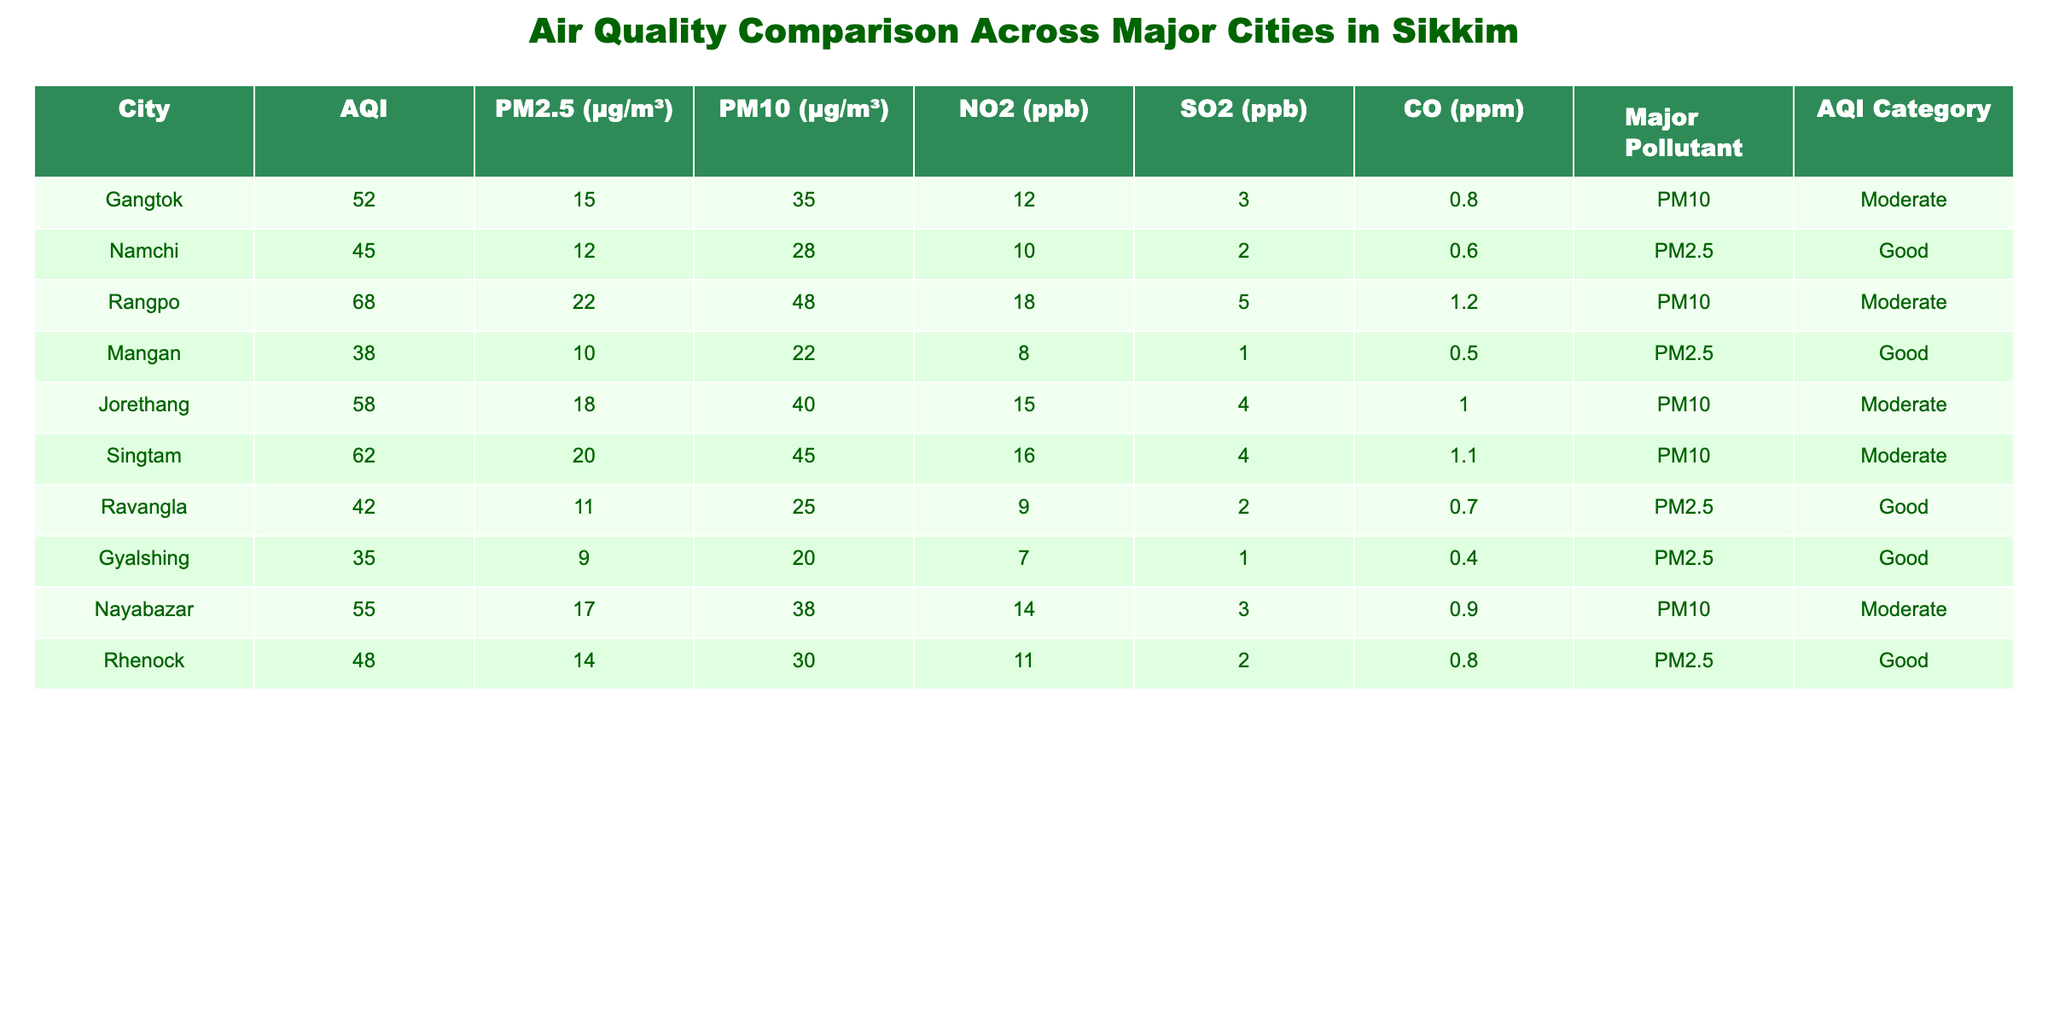What is the AQI value for Gangtok? The AQI value for Gangtok is found directly in the table under the AQI column, which states 52.
Answer: 52 Which city has the highest PM2.5 level? By comparing the PM2.5 values across all cities, the highest is 22 µg/m³ in Rangpo, making it the city with the highest PM2.5.
Answer: Rangpo Is the major pollutant in Namchi PM2.5? The major pollutant for Namchi, as indicated in the table, is PM2.5. Thus, the statement is true.
Answer: Yes What is the average PM10 level for cities categorized as Moderate? First, identify the cities categorized as Moderate: Gangtok, Rangpo, Jorethang, Singtam, and Nayabazar. Their PM10 levels are 35, 48, 40, 45, and 38 µg/m³. Sum these values (35 + 48 + 40 + 45 + 38 = 206) and divide by the number of cities (206 / 5 = 41.2).
Answer: 41.2 Is the AQI category for Gyalshing classified as Good? According to the table, Gyalshing has an AQI category of Good, corresponding to its AQI of 35. Therefore, the statement is true.
Answer: Yes How many cities have an AQI value below 50? Reviewing the AQI values, the cities with an AQI below 50 are Namchi (45), Mangan (38), and Ravangla (42). This gives a total of 3 cities.
Answer: 3 What is the difference between the PM2.5 levels of the city with the highest and the lowest PM2.5? The highest PM2.5 level is in Rangpo at 22 µg/m³, and the lowest is in Gyalshing at 9 µg/m³. The difference is calculated as (22 - 9 = 13).
Answer: 13 Which city has the lowest concentration of SO2? From the SO2 values provided, the lowest level is 7 ppb in Gyalshing.
Answer: Gyalshing What is the total CO level for all cities categorized as Good? The cities categorized as Good are Namchi, Mangan, Ravangla, and Gyalshing. Their CO levels are 0.6, 0.5, 0.7, and 0.4 ppm, respectively. Summing these values results in (0.6 + 0.5 + 0.7 + 0.4 = 2.2).
Answer: 2.2 